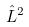<formula> <loc_0><loc_0><loc_500><loc_500>\hat { L } ^ { 2 }</formula> 